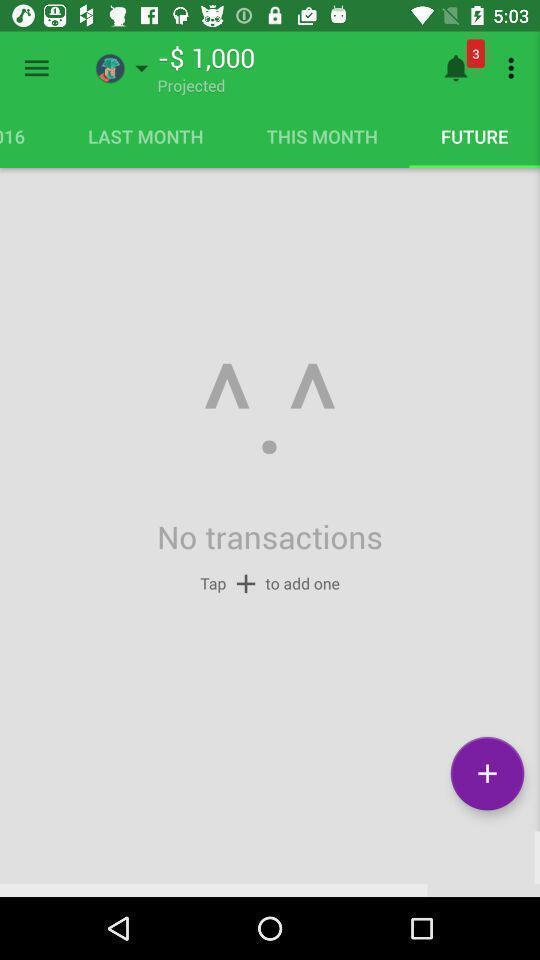Tell me what you see in this picture. Transactions page in finance app. 